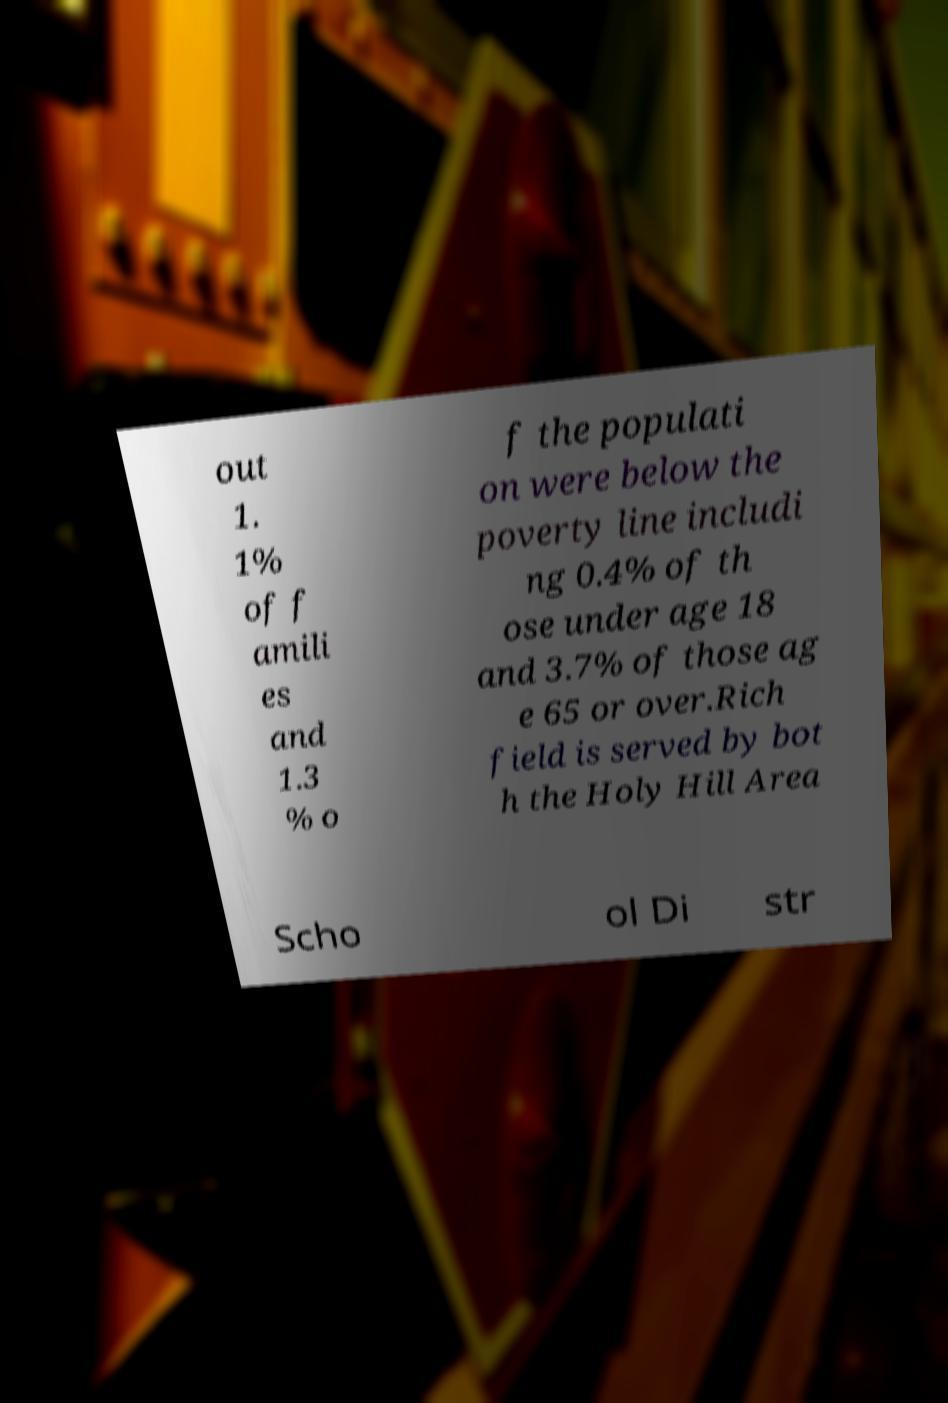Can you read and provide the text displayed in the image?This photo seems to have some interesting text. Can you extract and type it out for me? out 1. 1% of f amili es and 1.3 % o f the populati on were below the poverty line includi ng 0.4% of th ose under age 18 and 3.7% of those ag e 65 or over.Rich field is served by bot h the Holy Hill Area Scho ol Di str 